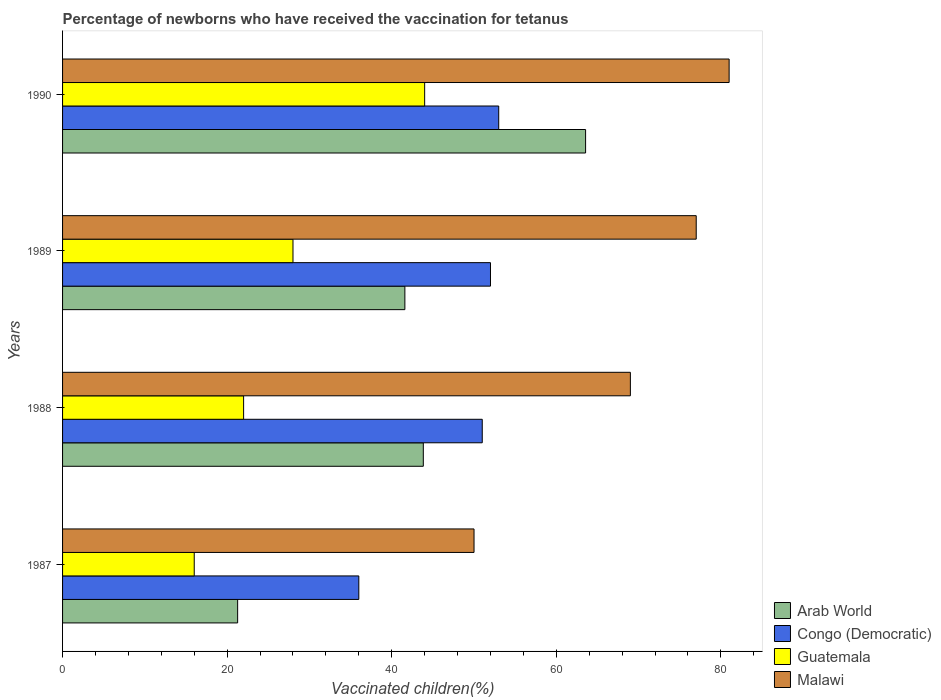How many different coloured bars are there?
Offer a terse response. 4. How many bars are there on the 3rd tick from the top?
Offer a very short reply. 4. What is the percentage of vaccinated children in Malawi in 1987?
Your answer should be compact. 50. Across all years, what is the minimum percentage of vaccinated children in Congo (Democratic)?
Ensure brevity in your answer.  36. In which year was the percentage of vaccinated children in Guatemala minimum?
Your response must be concise. 1987. What is the total percentage of vaccinated children in Malawi in the graph?
Keep it short and to the point. 277. What is the difference between the percentage of vaccinated children in Congo (Democratic) in 1990 and the percentage of vaccinated children in Arab World in 1987?
Give a very brief answer. 31.73. What is the average percentage of vaccinated children in Malawi per year?
Offer a terse response. 69.25. In how many years, is the percentage of vaccinated children in Malawi greater than 56 %?
Give a very brief answer. 3. What is the ratio of the percentage of vaccinated children in Congo (Democratic) in 1989 to that in 1990?
Ensure brevity in your answer.  0.98. Is the percentage of vaccinated children in Guatemala in 1988 less than that in 1990?
Offer a very short reply. Yes. What is the difference between the highest and the lowest percentage of vaccinated children in Arab World?
Your response must be concise. 42.28. In how many years, is the percentage of vaccinated children in Malawi greater than the average percentage of vaccinated children in Malawi taken over all years?
Give a very brief answer. 2. Is it the case that in every year, the sum of the percentage of vaccinated children in Congo (Democratic) and percentage of vaccinated children in Guatemala is greater than the sum of percentage of vaccinated children in Malawi and percentage of vaccinated children in Arab World?
Your answer should be compact. No. What does the 4th bar from the top in 1990 represents?
Your answer should be compact. Arab World. What does the 2nd bar from the bottom in 1989 represents?
Give a very brief answer. Congo (Democratic). How many bars are there?
Offer a terse response. 16. What is the difference between two consecutive major ticks on the X-axis?
Provide a short and direct response. 20. Are the values on the major ticks of X-axis written in scientific E-notation?
Keep it short and to the point. No. Where does the legend appear in the graph?
Provide a succinct answer. Bottom right. How are the legend labels stacked?
Provide a succinct answer. Vertical. What is the title of the graph?
Make the answer very short. Percentage of newborns who have received the vaccination for tetanus. What is the label or title of the X-axis?
Your answer should be compact. Vaccinated children(%). What is the label or title of the Y-axis?
Your answer should be compact. Years. What is the Vaccinated children(%) of Arab World in 1987?
Give a very brief answer. 21.27. What is the Vaccinated children(%) of Congo (Democratic) in 1987?
Make the answer very short. 36. What is the Vaccinated children(%) in Arab World in 1988?
Offer a terse response. 43.84. What is the Vaccinated children(%) in Congo (Democratic) in 1988?
Offer a very short reply. 51. What is the Vaccinated children(%) of Malawi in 1988?
Make the answer very short. 69. What is the Vaccinated children(%) of Arab World in 1989?
Provide a succinct answer. 41.6. What is the Vaccinated children(%) of Malawi in 1989?
Give a very brief answer. 77. What is the Vaccinated children(%) in Arab World in 1990?
Your answer should be compact. 63.56. What is the Vaccinated children(%) in Congo (Democratic) in 1990?
Offer a very short reply. 53. What is the Vaccinated children(%) in Guatemala in 1990?
Give a very brief answer. 44. Across all years, what is the maximum Vaccinated children(%) of Arab World?
Offer a terse response. 63.56. Across all years, what is the maximum Vaccinated children(%) in Guatemala?
Give a very brief answer. 44. Across all years, what is the maximum Vaccinated children(%) of Malawi?
Your answer should be compact. 81. Across all years, what is the minimum Vaccinated children(%) of Arab World?
Provide a succinct answer. 21.27. Across all years, what is the minimum Vaccinated children(%) in Congo (Democratic)?
Make the answer very short. 36. What is the total Vaccinated children(%) in Arab World in the graph?
Your answer should be compact. 170.27. What is the total Vaccinated children(%) of Congo (Democratic) in the graph?
Provide a succinct answer. 192. What is the total Vaccinated children(%) in Guatemala in the graph?
Keep it short and to the point. 110. What is the total Vaccinated children(%) of Malawi in the graph?
Your response must be concise. 277. What is the difference between the Vaccinated children(%) of Arab World in 1987 and that in 1988?
Offer a very short reply. -22.56. What is the difference between the Vaccinated children(%) of Congo (Democratic) in 1987 and that in 1988?
Your answer should be compact. -15. What is the difference between the Vaccinated children(%) of Guatemala in 1987 and that in 1988?
Keep it short and to the point. -6. What is the difference between the Vaccinated children(%) in Malawi in 1987 and that in 1988?
Your response must be concise. -19. What is the difference between the Vaccinated children(%) in Arab World in 1987 and that in 1989?
Give a very brief answer. -20.32. What is the difference between the Vaccinated children(%) in Congo (Democratic) in 1987 and that in 1989?
Keep it short and to the point. -16. What is the difference between the Vaccinated children(%) in Guatemala in 1987 and that in 1989?
Give a very brief answer. -12. What is the difference between the Vaccinated children(%) in Malawi in 1987 and that in 1989?
Your answer should be compact. -27. What is the difference between the Vaccinated children(%) of Arab World in 1987 and that in 1990?
Your answer should be compact. -42.28. What is the difference between the Vaccinated children(%) in Guatemala in 1987 and that in 1990?
Provide a short and direct response. -28. What is the difference between the Vaccinated children(%) of Malawi in 1987 and that in 1990?
Provide a succinct answer. -31. What is the difference between the Vaccinated children(%) of Arab World in 1988 and that in 1989?
Your response must be concise. 2.24. What is the difference between the Vaccinated children(%) in Congo (Democratic) in 1988 and that in 1989?
Keep it short and to the point. -1. What is the difference between the Vaccinated children(%) in Arab World in 1988 and that in 1990?
Keep it short and to the point. -19.72. What is the difference between the Vaccinated children(%) of Congo (Democratic) in 1988 and that in 1990?
Offer a terse response. -2. What is the difference between the Vaccinated children(%) of Malawi in 1988 and that in 1990?
Provide a short and direct response. -12. What is the difference between the Vaccinated children(%) of Arab World in 1989 and that in 1990?
Make the answer very short. -21.96. What is the difference between the Vaccinated children(%) in Congo (Democratic) in 1989 and that in 1990?
Offer a terse response. -1. What is the difference between the Vaccinated children(%) in Guatemala in 1989 and that in 1990?
Make the answer very short. -16. What is the difference between the Vaccinated children(%) of Malawi in 1989 and that in 1990?
Your answer should be compact. -4. What is the difference between the Vaccinated children(%) of Arab World in 1987 and the Vaccinated children(%) of Congo (Democratic) in 1988?
Offer a very short reply. -29.73. What is the difference between the Vaccinated children(%) of Arab World in 1987 and the Vaccinated children(%) of Guatemala in 1988?
Provide a short and direct response. -0.73. What is the difference between the Vaccinated children(%) in Arab World in 1987 and the Vaccinated children(%) in Malawi in 1988?
Provide a succinct answer. -47.73. What is the difference between the Vaccinated children(%) in Congo (Democratic) in 1987 and the Vaccinated children(%) in Malawi in 1988?
Make the answer very short. -33. What is the difference between the Vaccinated children(%) of Guatemala in 1987 and the Vaccinated children(%) of Malawi in 1988?
Offer a terse response. -53. What is the difference between the Vaccinated children(%) in Arab World in 1987 and the Vaccinated children(%) in Congo (Democratic) in 1989?
Your answer should be compact. -30.73. What is the difference between the Vaccinated children(%) in Arab World in 1987 and the Vaccinated children(%) in Guatemala in 1989?
Provide a succinct answer. -6.73. What is the difference between the Vaccinated children(%) in Arab World in 1987 and the Vaccinated children(%) in Malawi in 1989?
Offer a terse response. -55.73. What is the difference between the Vaccinated children(%) in Congo (Democratic) in 1987 and the Vaccinated children(%) in Malawi in 1989?
Give a very brief answer. -41. What is the difference between the Vaccinated children(%) of Guatemala in 1987 and the Vaccinated children(%) of Malawi in 1989?
Give a very brief answer. -61. What is the difference between the Vaccinated children(%) in Arab World in 1987 and the Vaccinated children(%) in Congo (Democratic) in 1990?
Make the answer very short. -31.73. What is the difference between the Vaccinated children(%) in Arab World in 1987 and the Vaccinated children(%) in Guatemala in 1990?
Keep it short and to the point. -22.73. What is the difference between the Vaccinated children(%) of Arab World in 1987 and the Vaccinated children(%) of Malawi in 1990?
Your answer should be compact. -59.73. What is the difference between the Vaccinated children(%) of Congo (Democratic) in 1987 and the Vaccinated children(%) of Guatemala in 1990?
Ensure brevity in your answer.  -8. What is the difference between the Vaccinated children(%) of Congo (Democratic) in 1987 and the Vaccinated children(%) of Malawi in 1990?
Provide a succinct answer. -45. What is the difference between the Vaccinated children(%) of Guatemala in 1987 and the Vaccinated children(%) of Malawi in 1990?
Provide a short and direct response. -65. What is the difference between the Vaccinated children(%) in Arab World in 1988 and the Vaccinated children(%) in Congo (Democratic) in 1989?
Provide a short and direct response. -8.16. What is the difference between the Vaccinated children(%) of Arab World in 1988 and the Vaccinated children(%) of Guatemala in 1989?
Your answer should be very brief. 15.84. What is the difference between the Vaccinated children(%) in Arab World in 1988 and the Vaccinated children(%) in Malawi in 1989?
Ensure brevity in your answer.  -33.16. What is the difference between the Vaccinated children(%) of Guatemala in 1988 and the Vaccinated children(%) of Malawi in 1989?
Provide a succinct answer. -55. What is the difference between the Vaccinated children(%) of Arab World in 1988 and the Vaccinated children(%) of Congo (Democratic) in 1990?
Your answer should be compact. -9.16. What is the difference between the Vaccinated children(%) of Arab World in 1988 and the Vaccinated children(%) of Guatemala in 1990?
Offer a terse response. -0.16. What is the difference between the Vaccinated children(%) of Arab World in 1988 and the Vaccinated children(%) of Malawi in 1990?
Make the answer very short. -37.16. What is the difference between the Vaccinated children(%) of Congo (Democratic) in 1988 and the Vaccinated children(%) of Guatemala in 1990?
Make the answer very short. 7. What is the difference between the Vaccinated children(%) of Congo (Democratic) in 1988 and the Vaccinated children(%) of Malawi in 1990?
Provide a short and direct response. -30. What is the difference between the Vaccinated children(%) in Guatemala in 1988 and the Vaccinated children(%) in Malawi in 1990?
Give a very brief answer. -59. What is the difference between the Vaccinated children(%) in Arab World in 1989 and the Vaccinated children(%) in Congo (Democratic) in 1990?
Your response must be concise. -11.4. What is the difference between the Vaccinated children(%) in Arab World in 1989 and the Vaccinated children(%) in Guatemala in 1990?
Provide a succinct answer. -2.4. What is the difference between the Vaccinated children(%) of Arab World in 1989 and the Vaccinated children(%) of Malawi in 1990?
Your answer should be compact. -39.4. What is the difference between the Vaccinated children(%) of Guatemala in 1989 and the Vaccinated children(%) of Malawi in 1990?
Your answer should be very brief. -53. What is the average Vaccinated children(%) in Arab World per year?
Give a very brief answer. 42.57. What is the average Vaccinated children(%) in Congo (Democratic) per year?
Your answer should be very brief. 48. What is the average Vaccinated children(%) in Guatemala per year?
Ensure brevity in your answer.  27.5. What is the average Vaccinated children(%) in Malawi per year?
Your response must be concise. 69.25. In the year 1987, what is the difference between the Vaccinated children(%) of Arab World and Vaccinated children(%) of Congo (Democratic)?
Provide a short and direct response. -14.73. In the year 1987, what is the difference between the Vaccinated children(%) in Arab World and Vaccinated children(%) in Guatemala?
Offer a very short reply. 5.27. In the year 1987, what is the difference between the Vaccinated children(%) in Arab World and Vaccinated children(%) in Malawi?
Give a very brief answer. -28.73. In the year 1987, what is the difference between the Vaccinated children(%) in Congo (Democratic) and Vaccinated children(%) in Guatemala?
Your answer should be compact. 20. In the year 1987, what is the difference between the Vaccinated children(%) of Congo (Democratic) and Vaccinated children(%) of Malawi?
Keep it short and to the point. -14. In the year 1987, what is the difference between the Vaccinated children(%) of Guatemala and Vaccinated children(%) of Malawi?
Make the answer very short. -34. In the year 1988, what is the difference between the Vaccinated children(%) in Arab World and Vaccinated children(%) in Congo (Democratic)?
Your response must be concise. -7.16. In the year 1988, what is the difference between the Vaccinated children(%) of Arab World and Vaccinated children(%) of Guatemala?
Ensure brevity in your answer.  21.84. In the year 1988, what is the difference between the Vaccinated children(%) of Arab World and Vaccinated children(%) of Malawi?
Provide a short and direct response. -25.16. In the year 1988, what is the difference between the Vaccinated children(%) of Congo (Democratic) and Vaccinated children(%) of Malawi?
Offer a terse response. -18. In the year 1988, what is the difference between the Vaccinated children(%) in Guatemala and Vaccinated children(%) in Malawi?
Your response must be concise. -47. In the year 1989, what is the difference between the Vaccinated children(%) of Arab World and Vaccinated children(%) of Congo (Democratic)?
Your response must be concise. -10.4. In the year 1989, what is the difference between the Vaccinated children(%) of Arab World and Vaccinated children(%) of Guatemala?
Your response must be concise. 13.6. In the year 1989, what is the difference between the Vaccinated children(%) of Arab World and Vaccinated children(%) of Malawi?
Your answer should be very brief. -35.4. In the year 1989, what is the difference between the Vaccinated children(%) of Guatemala and Vaccinated children(%) of Malawi?
Make the answer very short. -49. In the year 1990, what is the difference between the Vaccinated children(%) in Arab World and Vaccinated children(%) in Congo (Democratic)?
Keep it short and to the point. 10.56. In the year 1990, what is the difference between the Vaccinated children(%) of Arab World and Vaccinated children(%) of Guatemala?
Keep it short and to the point. 19.56. In the year 1990, what is the difference between the Vaccinated children(%) of Arab World and Vaccinated children(%) of Malawi?
Make the answer very short. -17.44. In the year 1990, what is the difference between the Vaccinated children(%) in Congo (Democratic) and Vaccinated children(%) in Malawi?
Your response must be concise. -28. In the year 1990, what is the difference between the Vaccinated children(%) in Guatemala and Vaccinated children(%) in Malawi?
Provide a short and direct response. -37. What is the ratio of the Vaccinated children(%) of Arab World in 1987 to that in 1988?
Make the answer very short. 0.49. What is the ratio of the Vaccinated children(%) in Congo (Democratic) in 1987 to that in 1988?
Keep it short and to the point. 0.71. What is the ratio of the Vaccinated children(%) in Guatemala in 1987 to that in 1988?
Your response must be concise. 0.73. What is the ratio of the Vaccinated children(%) in Malawi in 1987 to that in 1988?
Your answer should be compact. 0.72. What is the ratio of the Vaccinated children(%) in Arab World in 1987 to that in 1989?
Keep it short and to the point. 0.51. What is the ratio of the Vaccinated children(%) in Congo (Democratic) in 1987 to that in 1989?
Your response must be concise. 0.69. What is the ratio of the Vaccinated children(%) in Malawi in 1987 to that in 1989?
Provide a short and direct response. 0.65. What is the ratio of the Vaccinated children(%) in Arab World in 1987 to that in 1990?
Offer a very short reply. 0.33. What is the ratio of the Vaccinated children(%) in Congo (Democratic) in 1987 to that in 1990?
Your response must be concise. 0.68. What is the ratio of the Vaccinated children(%) in Guatemala in 1987 to that in 1990?
Your answer should be very brief. 0.36. What is the ratio of the Vaccinated children(%) in Malawi in 1987 to that in 1990?
Offer a terse response. 0.62. What is the ratio of the Vaccinated children(%) in Arab World in 1988 to that in 1989?
Offer a very short reply. 1.05. What is the ratio of the Vaccinated children(%) of Congo (Democratic) in 1988 to that in 1989?
Provide a short and direct response. 0.98. What is the ratio of the Vaccinated children(%) in Guatemala in 1988 to that in 1989?
Make the answer very short. 0.79. What is the ratio of the Vaccinated children(%) of Malawi in 1988 to that in 1989?
Make the answer very short. 0.9. What is the ratio of the Vaccinated children(%) of Arab World in 1988 to that in 1990?
Provide a succinct answer. 0.69. What is the ratio of the Vaccinated children(%) in Congo (Democratic) in 1988 to that in 1990?
Your answer should be compact. 0.96. What is the ratio of the Vaccinated children(%) in Guatemala in 1988 to that in 1990?
Provide a short and direct response. 0.5. What is the ratio of the Vaccinated children(%) of Malawi in 1988 to that in 1990?
Your response must be concise. 0.85. What is the ratio of the Vaccinated children(%) of Arab World in 1989 to that in 1990?
Keep it short and to the point. 0.65. What is the ratio of the Vaccinated children(%) of Congo (Democratic) in 1989 to that in 1990?
Ensure brevity in your answer.  0.98. What is the ratio of the Vaccinated children(%) in Guatemala in 1989 to that in 1990?
Your answer should be compact. 0.64. What is the ratio of the Vaccinated children(%) of Malawi in 1989 to that in 1990?
Ensure brevity in your answer.  0.95. What is the difference between the highest and the second highest Vaccinated children(%) of Arab World?
Provide a short and direct response. 19.72. What is the difference between the highest and the second highest Vaccinated children(%) in Congo (Democratic)?
Offer a terse response. 1. What is the difference between the highest and the second highest Vaccinated children(%) of Guatemala?
Make the answer very short. 16. What is the difference between the highest and the second highest Vaccinated children(%) in Malawi?
Provide a succinct answer. 4. What is the difference between the highest and the lowest Vaccinated children(%) of Arab World?
Ensure brevity in your answer.  42.28. What is the difference between the highest and the lowest Vaccinated children(%) of Congo (Democratic)?
Offer a terse response. 17. What is the difference between the highest and the lowest Vaccinated children(%) in Guatemala?
Your answer should be very brief. 28. 